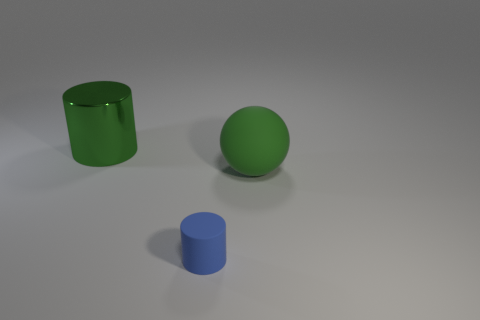Add 1 large metal cylinders. How many objects exist? 4 Subtract all cylinders. How many objects are left? 1 Add 1 small blue rubber objects. How many small blue rubber objects exist? 2 Subtract 1 green balls. How many objects are left? 2 Subtract all green matte spheres. Subtract all shiny objects. How many objects are left? 1 Add 1 blue cylinders. How many blue cylinders are left? 2 